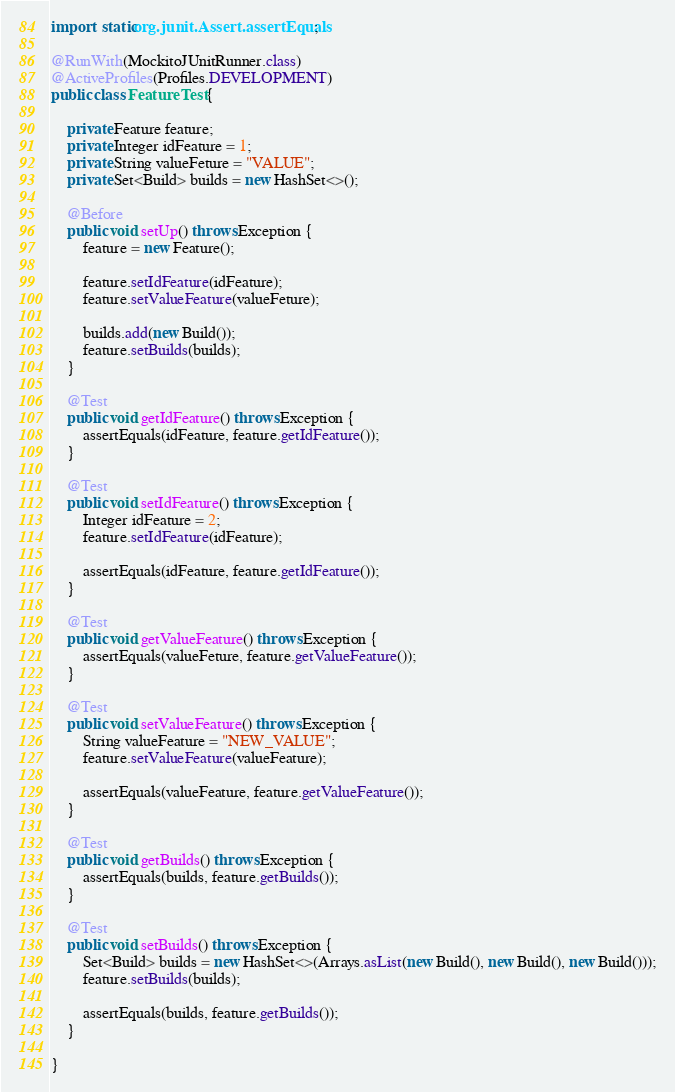<code> <loc_0><loc_0><loc_500><loc_500><_Java_>import static org.junit.Assert.assertEquals;

@RunWith(MockitoJUnitRunner.class)
@ActiveProfiles(Profiles.DEVELOPMENT)
public class FeatureTest {

    private Feature feature;
    private Integer idFeature = 1;
    private String valueFeture = "VALUE";
    private Set<Build> builds = new HashSet<>();

    @Before
    public void setUp() throws Exception {
        feature = new Feature();

        feature.setIdFeature(idFeature);
        feature.setValueFeature(valueFeture);

        builds.add(new Build());
        feature.setBuilds(builds);
    }

    @Test
    public void getIdFeature() throws Exception {
        assertEquals(idFeature, feature.getIdFeature());
    }

    @Test
    public void setIdFeature() throws Exception {
        Integer idFeature = 2;
        feature.setIdFeature(idFeature);

        assertEquals(idFeature, feature.getIdFeature());
    }

    @Test
    public void getValueFeature() throws Exception {
        assertEquals(valueFeture, feature.getValueFeature());
    }

    @Test
    public void setValueFeature() throws Exception {
        String valueFeature = "NEW_VALUE";
        feature.setValueFeature(valueFeature);

        assertEquals(valueFeature, feature.getValueFeature());
    }

    @Test
    public void getBuilds() throws Exception {
        assertEquals(builds, feature.getBuilds());
    }

    @Test
    public void setBuilds() throws Exception {
        Set<Build> builds = new HashSet<>(Arrays.asList(new Build(), new Build(), new Build()));
        feature.setBuilds(builds);

        assertEquals(builds, feature.getBuilds());
    }

}</code> 